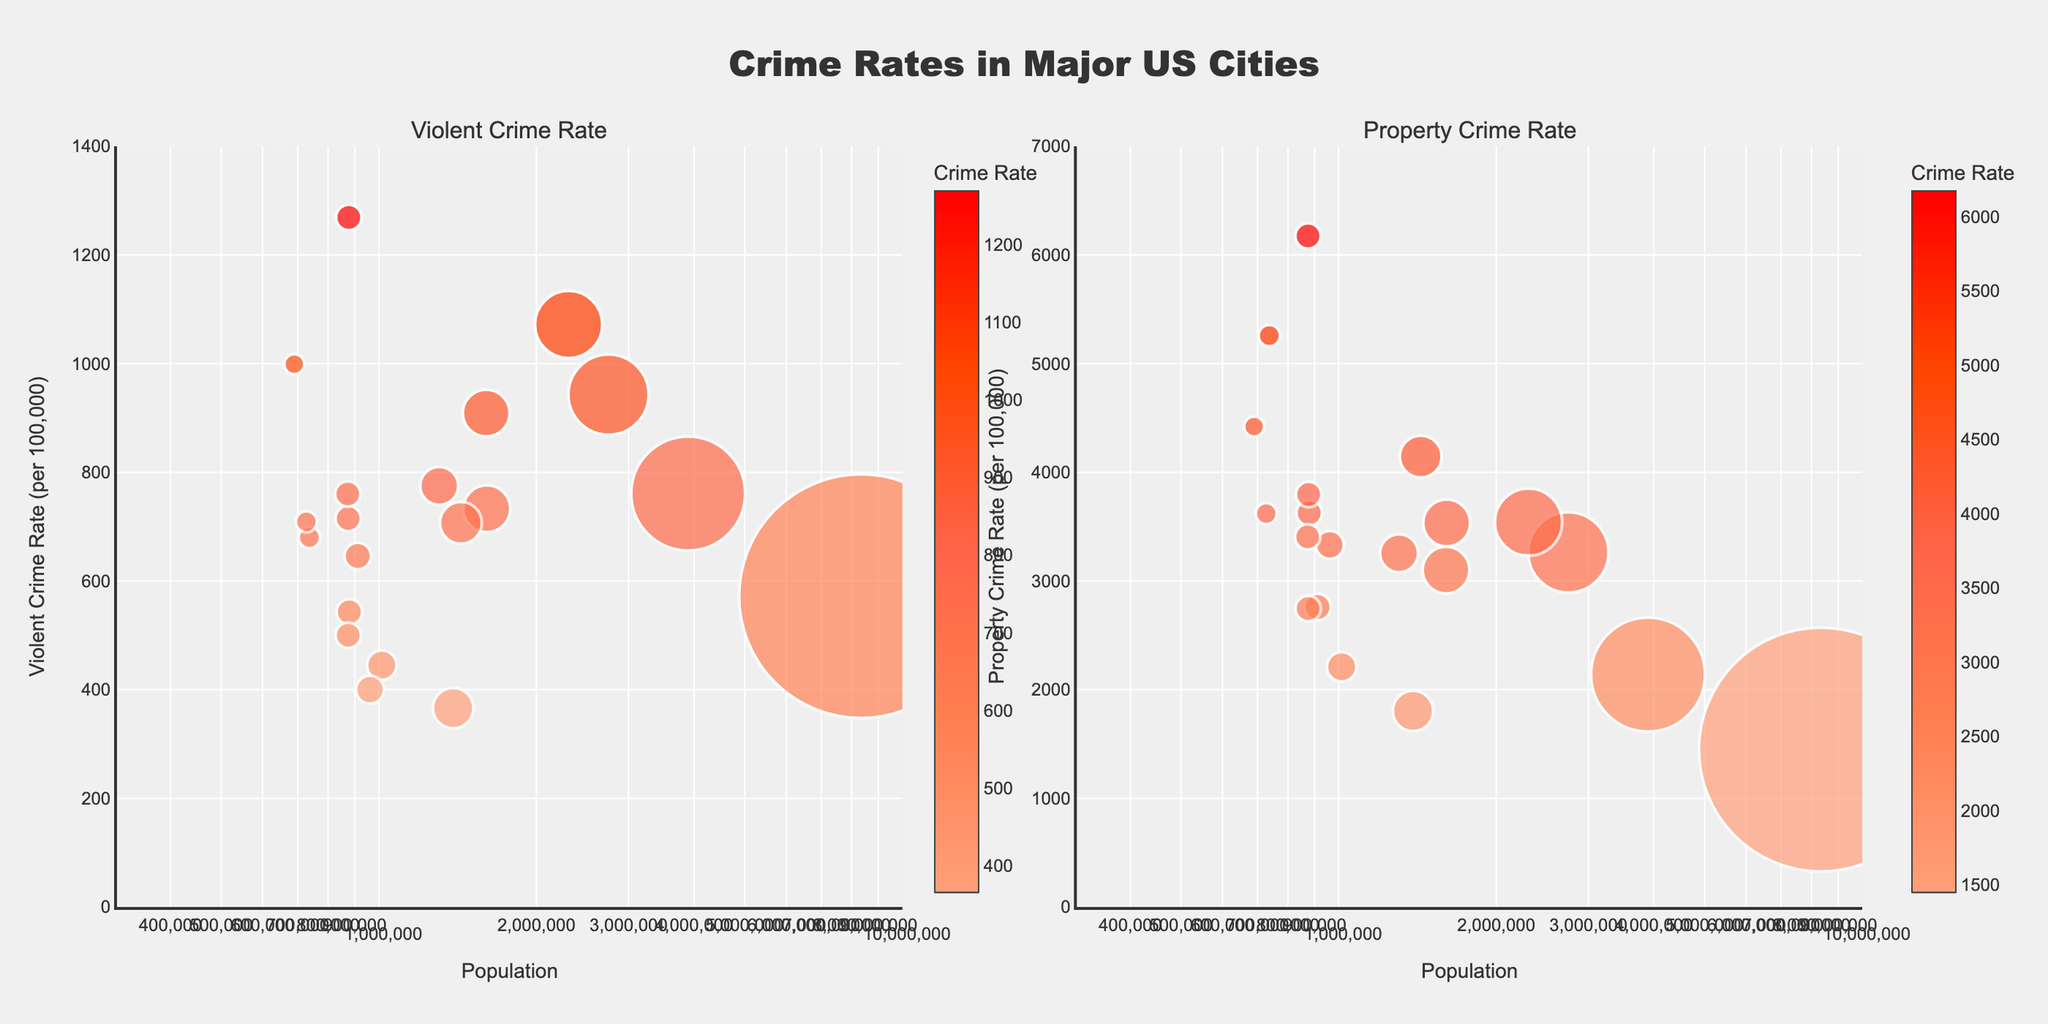What is the title of the subplot? The title of the subplot is located at the top of the figure, centered and in bold font. It reads "Crime Rates in Major US Cities".
Answer: Crime Rates in Major US Cities How many cities are represented in the figure? The number of cities can be counted by observing the number of bubble points in either chart. Both charts should have the same number of cities. Since each bubble represents a city, counting them in one subplot will give the answer.
Answer: 20 Which city has the highest violent crime rate? By examining the vertical axis in the "Violent Crime Rate" subplot, we can identify the city with the bubble at the highest point. The hover information can be used for precise identification.
Answer: Indianapolis Which city has the lowest property crime rate? Observe the vertical axis in the "Property Crime Rate" subplot and identify the city with the bubble at the lowest point. The hover information will show San Diego is positioned at the lowest in the property crime axis.
Answer: San Diego Which city has the largest population? The bubble size represents population; thus, the city with the largest bubble in either subplot should be identified. Hovering over this bubble will show the city’s name and population.
Answer: New York City Compare the violent crime rate between New York City and Washington D.C. Locate New York City and Washington D.C. in the "Violent Crime Rate" subplot. New York City's violent crime rate is shown lower on the y-axis compared to Washington D.C.
Answer: New York City has a lower violent crime rate than Washington D.C Which city has a higher property crime rate, Dallas or Charlotte? Observe the bubbles for Dallas and Charlotte in the "Property Crime Rate" subplot. Check their vertical positions to compare their property crime rates.
Answer: Dallas Does the size of the city (population) correlate with the violent crime rate? To answer this, observe both the size and vertical position of the bubbles in the "Violent Crime Rate" subplot. Generally, larger bubbles (indicating larger populations) are not consistently higher or lower on the y-axis.
Answer: No clear correlation 